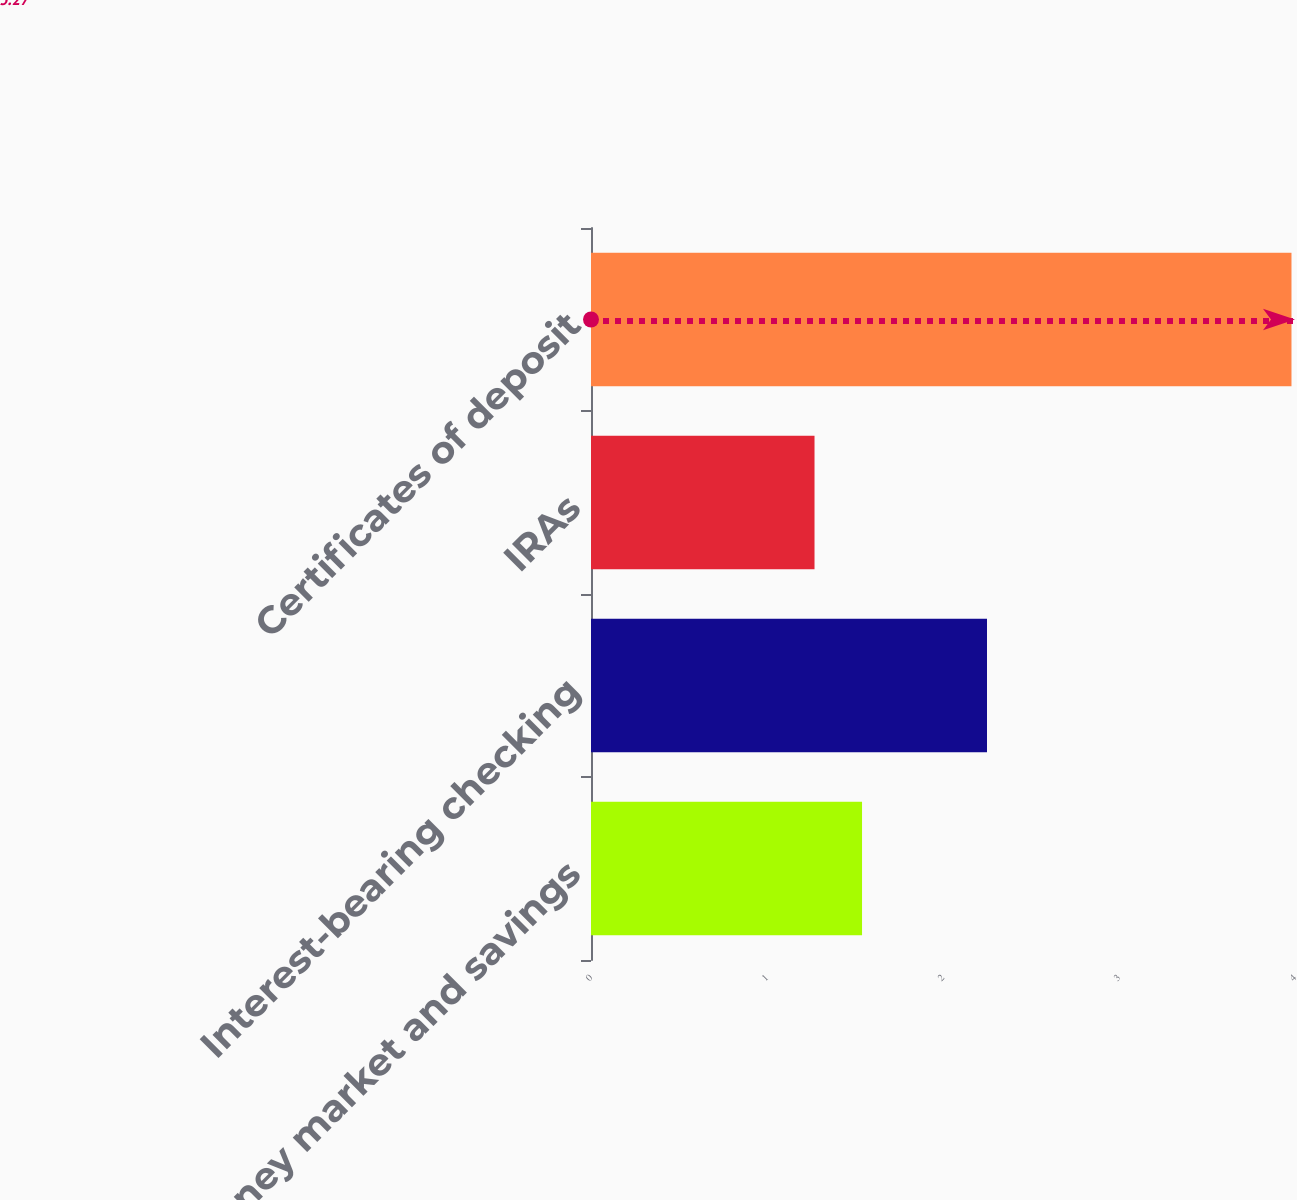Convert chart to OTSL. <chart><loc_0><loc_0><loc_500><loc_500><bar_chart><fcel>Money market and savings<fcel>Interest-bearing checking<fcel>IRAs<fcel>Certificates of deposit<nl><fcel>1.54<fcel>2.25<fcel>1.27<fcel>3.98<nl></chart> 